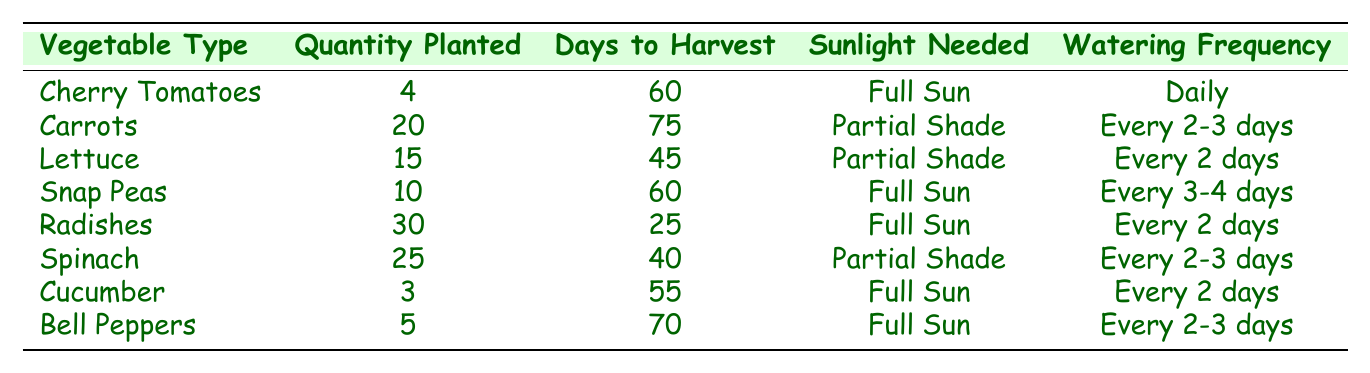What is the quantity of Cherry Tomatoes planted? The table lists Cherry Tomatoes with a quantity of 4 planted.
Answer: 4 How many days does it take to harvest Radishes? According to the table, Radishes take 25 days to harvest.
Answer: 25 Which vegetable needs partial shade and is planted in the greatest quantity? The table shows Carrots (20), Lettuce (15), and Spinach (25) need partial shade. Spinach has the greatest quantity at 25.
Answer: Spinach How often should Cucumber be watered? The table indicates that Cucumber should be watered every 2 days.
Answer: Every 2 days What is the average number of days to harvest for the vegetables that need full sun? The timings for full sun vegetables are: Cherry Tomatoes (60), Snap Peas (60), Radishes (25), Cucumber (55), and Bell Peppers (70). The average is (60 + 60 + 25 + 55 + 70) / 5 = 54.
Answer: 54 Is it true that Spinach requires more frequent watering than Snap Peas? The table states that Spinach is watered every 2-3 days, while Snap Peas are watered every 3-4 days. So, Spinach requires more frequent watering.
Answer: Yes How many total vegetables were planted that require partial shade? The total quantities for partial shade vegetables are: Carrots (20), Lettuce (15), and Spinach (25). Therefore, the total is 20 + 15 + 25 = 60.
Answer: 60 Which vegetable has the longest days to harvest? The longest days to harvest listed in the table is for Carrots, which takes 75 days.
Answer: Carrots Are there more vegetables needing full sun or partial shade? The table shows 5 vegetables needing full sun (Cherry Tomatoes, Snap Peas, Radishes, Cucumber, Bell Peppers) and 3 needing partial shade (Carrots, Lettuce, Spinach). Therefore, there are more vegetables needing full sun.
Answer: Full sun What is the total quantity of Radishes and Lettuce planted? The quantity of Radishes is 30 and Lettuce is 15. Adding them gives 30 + 15 = 45.
Answer: 45 